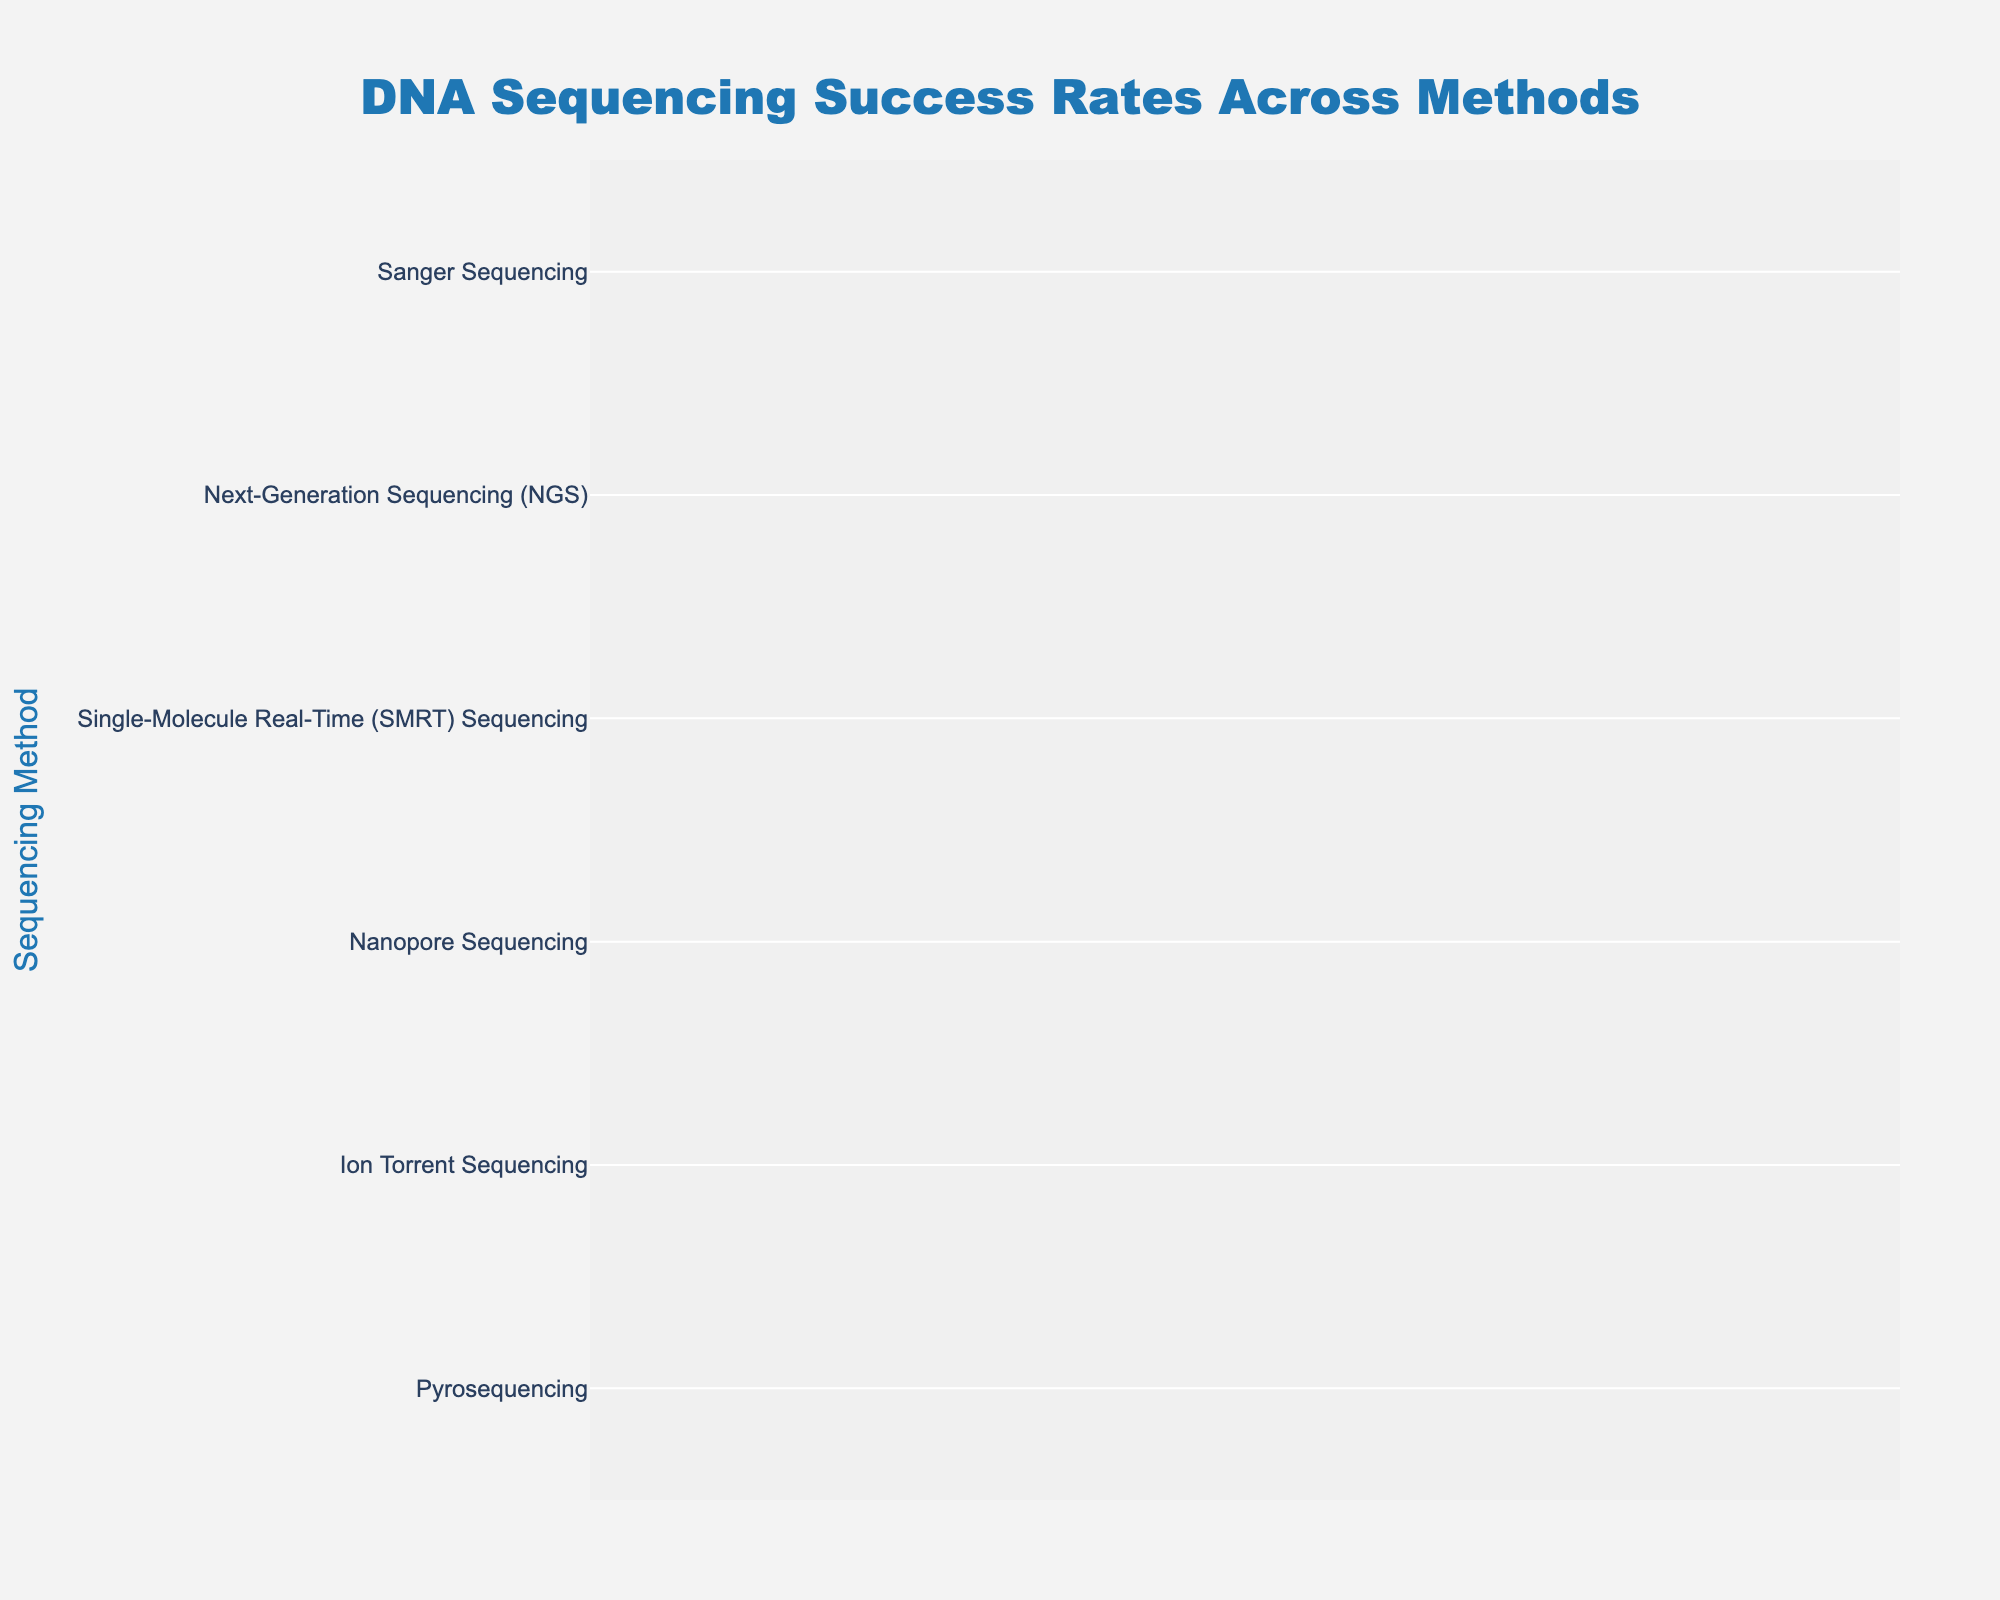What is the title of the funnel chart? The title is usually displayed at the top of the chart. According to the provided information, the title of the funnel chart should be visible and clearly stated.
Answer: DNA Sequencing Success Rates Across Methods Which sequencing method has the highest success rate? To identify the method with the highest success rate, look for the largest bar at the top of the funnel chart. According to the data, "Sanger Sequencing" has the highest success rate.
Answer: Sanger Sequencing How many data points are represented in the funnel chart? Count the number of bars (sections) in the funnel chart, each representing a different sequencing method. According to the data provided, there are six methods listed.
Answer: 6 What is the success rate of Ion Torrent Sequencing? Locate the section of the funnel chart labeled "Ion Torrent Sequencing" and read the success rate value displayed inside the bar. According to the data, the success rate is 82%.
Answer: 82% What is the difference in success rates between the highest and lowest performing methods? Subtract the success rate of the lowest performing method from the success rate of the highest performing method. According to the data, Sanger Sequencing has 95% and Pyrosequencing has 78%, so the difference is 95% - 78%.
Answer: 17% Which method's success rate is closest to the average success rate of all methods? First, calculate the average success rate by summing all the success rates and dividing by the number of methods. The sum is 95 + 92 + 88 + 85 + 82 + 78 = 520, and the average is 520/6 ≈ 86.67%. The method with a success rate closest to 86.67% is Nanopore Sequencing with 85%.
Answer: Nanopore Sequencing Arrange the sequencing methods in descending order of their success rates. The funnel chart already arranges methods from highest to lowest success rates. According to the data: Sanger Sequencing (95%), Next-Generation Sequencing (NGS) (92%), Single-Molecule Real-Time (SMRT) Sequencing (88%), Nanopore Sequencing (85%), Ion Torrent Sequencing (82%), Pyrosequencing (78%).
Answer: Sanger Sequencing, Next-Generation Sequencing (NGS), Single-Molecule Real-Time (SMRT) Sequencing, Nanopore Sequencing, Ion Torrent Sequencing, Pyrosequencing What percentage of the initial success rate (Sanger Sequencing) does Pyrosequencing represent? To find this percentage, divide Pyrosequencing's success rate by Sanger Sequencing's success rate and multiply by 100. That is (78/95) * 100 ≈ 82.11%.
Answer: 82.11% 